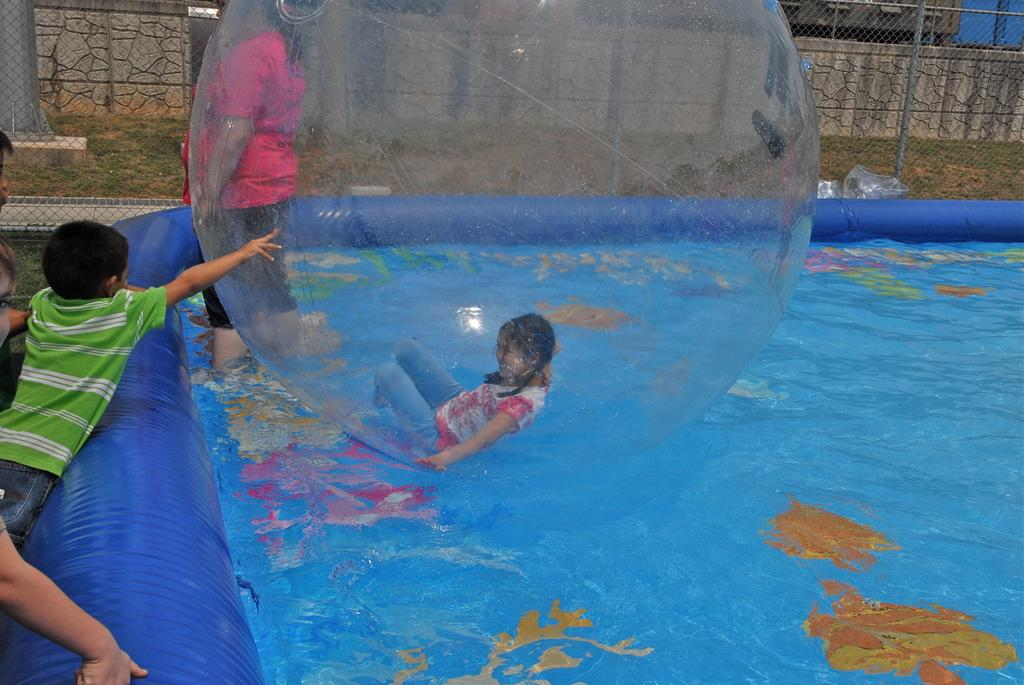What are the children in the image doing? The children in the image are playing. Can you describe the person on the left side of the image? There is a person standing on the left side of the image. What can be seen in the background of the image? There is a wall visible in the background of the image. What holiday is being celebrated in the image? There is no indication of a holiday being celebrated in the image. What type of station is depicted in the image? There is no station present in the image. 